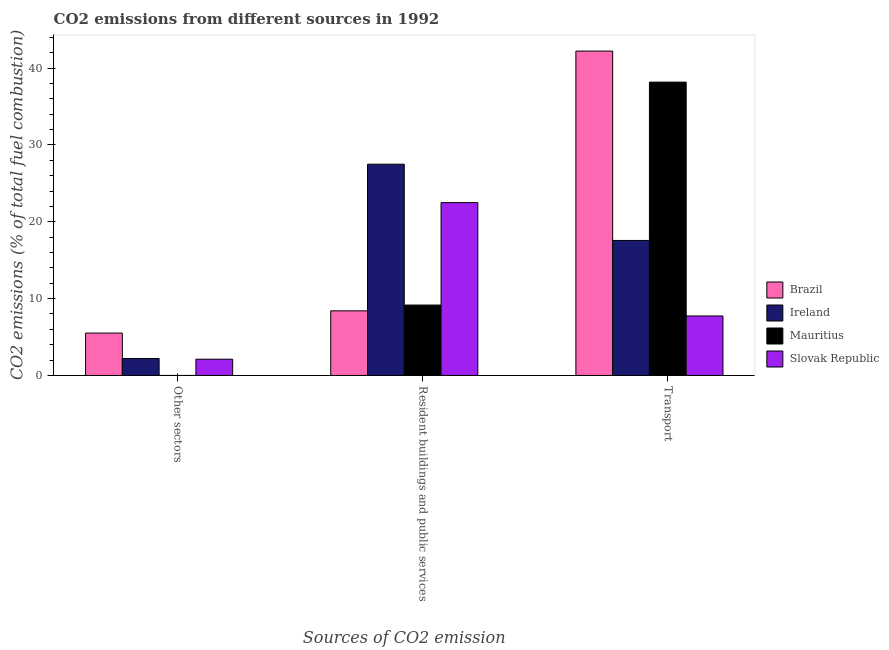How many different coloured bars are there?
Your response must be concise. 4. How many bars are there on the 1st tick from the left?
Ensure brevity in your answer.  3. How many bars are there on the 1st tick from the right?
Keep it short and to the point. 4. What is the label of the 1st group of bars from the left?
Your answer should be very brief. Other sectors. What is the percentage of co2 emissions from transport in Brazil?
Provide a succinct answer. 42.2. Across all countries, what is the maximum percentage of co2 emissions from resident buildings and public services?
Offer a very short reply. 27.49. Across all countries, what is the minimum percentage of co2 emissions from transport?
Your response must be concise. 7.74. In which country was the percentage of co2 emissions from transport maximum?
Offer a very short reply. Brazil. What is the total percentage of co2 emissions from transport in the graph?
Offer a very short reply. 105.68. What is the difference between the percentage of co2 emissions from other sectors in Ireland and that in Brazil?
Offer a terse response. -3.31. What is the difference between the percentage of co2 emissions from other sectors in Mauritius and the percentage of co2 emissions from transport in Slovak Republic?
Give a very brief answer. -7.74. What is the average percentage of co2 emissions from transport per country?
Offer a terse response. 26.42. What is the difference between the percentage of co2 emissions from other sectors and percentage of co2 emissions from transport in Brazil?
Your answer should be compact. -36.69. In how many countries, is the percentage of co2 emissions from resident buildings and public services greater than 34 %?
Offer a terse response. 0. What is the ratio of the percentage of co2 emissions from resident buildings and public services in Brazil to that in Ireland?
Provide a succinct answer. 0.31. Is the percentage of co2 emissions from resident buildings and public services in Mauritius less than that in Brazil?
Keep it short and to the point. No. Is the difference between the percentage of co2 emissions from resident buildings and public services in Slovak Republic and Ireland greater than the difference between the percentage of co2 emissions from other sectors in Slovak Republic and Ireland?
Give a very brief answer. No. What is the difference between the highest and the second highest percentage of co2 emissions from resident buildings and public services?
Provide a short and direct response. 5. What is the difference between the highest and the lowest percentage of co2 emissions from resident buildings and public services?
Offer a very short reply. 19.08. In how many countries, is the percentage of co2 emissions from transport greater than the average percentage of co2 emissions from transport taken over all countries?
Provide a succinct answer. 2. Is it the case that in every country, the sum of the percentage of co2 emissions from other sectors and percentage of co2 emissions from resident buildings and public services is greater than the percentage of co2 emissions from transport?
Your answer should be very brief. No. Are all the bars in the graph horizontal?
Offer a very short reply. No. How many countries are there in the graph?
Your answer should be very brief. 4. Where does the legend appear in the graph?
Offer a terse response. Center right. How are the legend labels stacked?
Offer a very short reply. Vertical. What is the title of the graph?
Offer a very short reply. CO2 emissions from different sources in 1992. What is the label or title of the X-axis?
Offer a very short reply. Sources of CO2 emission. What is the label or title of the Y-axis?
Offer a very short reply. CO2 emissions (% of total fuel combustion). What is the CO2 emissions (% of total fuel combustion) of Brazil in Other sectors?
Give a very brief answer. 5.51. What is the CO2 emissions (% of total fuel combustion) of Ireland in Other sectors?
Provide a succinct answer. 2.21. What is the CO2 emissions (% of total fuel combustion) in Mauritius in Other sectors?
Ensure brevity in your answer.  0. What is the CO2 emissions (% of total fuel combustion) of Slovak Republic in Other sectors?
Your answer should be very brief. 2.12. What is the CO2 emissions (% of total fuel combustion) in Brazil in Resident buildings and public services?
Ensure brevity in your answer.  8.41. What is the CO2 emissions (% of total fuel combustion) of Ireland in Resident buildings and public services?
Ensure brevity in your answer.  27.49. What is the CO2 emissions (% of total fuel combustion) in Mauritius in Resident buildings and public services?
Offer a very short reply. 9.16. What is the CO2 emissions (% of total fuel combustion) of Slovak Republic in Resident buildings and public services?
Your answer should be very brief. 22.49. What is the CO2 emissions (% of total fuel combustion) in Brazil in Transport?
Keep it short and to the point. 42.2. What is the CO2 emissions (% of total fuel combustion) in Ireland in Transport?
Your response must be concise. 17.57. What is the CO2 emissions (% of total fuel combustion) in Mauritius in Transport?
Your answer should be compact. 38.17. What is the CO2 emissions (% of total fuel combustion) in Slovak Republic in Transport?
Your response must be concise. 7.74. Across all Sources of CO2 emission, what is the maximum CO2 emissions (% of total fuel combustion) in Brazil?
Your response must be concise. 42.2. Across all Sources of CO2 emission, what is the maximum CO2 emissions (% of total fuel combustion) in Ireland?
Ensure brevity in your answer.  27.49. Across all Sources of CO2 emission, what is the maximum CO2 emissions (% of total fuel combustion) in Mauritius?
Offer a terse response. 38.17. Across all Sources of CO2 emission, what is the maximum CO2 emissions (% of total fuel combustion) of Slovak Republic?
Your answer should be compact. 22.49. Across all Sources of CO2 emission, what is the minimum CO2 emissions (% of total fuel combustion) in Brazil?
Your answer should be compact. 5.51. Across all Sources of CO2 emission, what is the minimum CO2 emissions (% of total fuel combustion) in Ireland?
Offer a terse response. 2.21. Across all Sources of CO2 emission, what is the minimum CO2 emissions (% of total fuel combustion) of Slovak Republic?
Your answer should be very brief. 2.12. What is the total CO2 emissions (% of total fuel combustion) of Brazil in the graph?
Offer a terse response. 56.13. What is the total CO2 emissions (% of total fuel combustion) of Ireland in the graph?
Keep it short and to the point. 47.26. What is the total CO2 emissions (% of total fuel combustion) of Mauritius in the graph?
Ensure brevity in your answer.  47.33. What is the total CO2 emissions (% of total fuel combustion) in Slovak Republic in the graph?
Offer a very short reply. 32.35. What is the difference between the CO2 emissions (% of total fuel combustion) in Brazil in Other sectors and that in Resident buildings and public services?
Provide a short and direct response. -2.9. What is the difference between the CO2 emissions (% of total fuel combustion) in Ireland in Other sectors and that in Resident buildings and public services?
Your answer should be compact. -25.28. What is the difference between the CO2 emissions (% of total fuel combustion) in Slovak Republic in Other sectors and that in Resident buildings and public services?
Offer a terse response. -20.37. What is the difference between the CO2 emissions (% of total fuel combustion) of Brazil in Other sectors and that in Transport?
Provide a short and direct response. -36.69. What is the difference between the CO2 emissions (% of total fuel combustion) in Ireland in Other sectors and that in Transport?
Give a very brief answer. -15.36. What is the difference between the CO2 emissions (% of total fuel combustion) in Slovak Republic in Other sectors and that in Transport?
Keep it short and to the point. -5.62. What is the difference between the CO2 emissions (% of total fuel combustion) of Brazil in Resident buildings and public services and that in Transport?
Offer a terse response. -33.79. What is the difference between the CO2 emissions (% of total fuel combustion) in Ireland in Resident buildings and public services and that in Transport?
Give a very brief answer. 9.92. What is the difference between the CO2 emissions (% of total fuel combustion) in Mauritius in Resident buildings and public services and that in Transport?
Offer a very short reply. -29.01. What is the difference between the CO2 emissions (% of total fuel combustion) in Slovak Republic in Resident buildings and public services and that in Transport?
Keep it short and to the point. 14.75. What is the difference between the CO2 emissions (% of total fuel combustion) in Brazil in Other sectors and the CO2 emissions (% of total fuel combustion) in Ireland in Resident buildings and public services?
Your answer should be very brief. -21.97. What is the difference between the CO2 emissions (% of total fuel combustion) in Brazil in Other sectors and the CO2 emissions (% of total fuel combustion) in Mauritius in Resident buildings and public services?
Keep it short and to the point. -3.65. What is the difference between the CO2 emissions (% of total fuel combustion) of Brazil in Other sectors and the CO2 emissions (% of total fuel combustion) of Slovak Republic in Resident buildings and public services?
Offer a very short reply. -16.98. What is the difference between the CO2 emissions (% of total fuel combustion) in Ireland in Other sectors and the CO2 emissions (% of total fuel combustion) in Mauritius in Resident buildings and public services?
Provide a succinct answer. -6.95. What is the difference between the CO2 emissions (% of total fuel combustion) of Ireland in Other sectors and the CO2 emissions (% of total fuel combustion) of Slovak Republic in Resident buildings and public services?
Keep it short and to the point. -20.28. What is the difference between the CO2 emissions (% of total fuel combustion) of Brazil in Other sectors and the CO2 emissions (% of total fuel combustion) of Ireland in Transport?
Provide a short and direct response. -12.05. What is the difference between the CO2 emissions (% of total fuel combustion) in Brazil in Other sectors and the CO2 emissions (% of total fuel combustion) in Mauritius in Transport?
Provide a short and direct response. -32.65. What is the difference between the CO2 emissions (% of total fuel combustion) in Brazil in Other sectors and the CO2 emissions (% of total fuel combustion) in Slovak Republic in Transport?
Provide a short and direct response. -2.23. What is the difference between the CO2 emissions (% of total fuel combustion) in Ireland in Other sectors and the CO2 emissions (% of total fuel combustion) in Mauritius in Transport?
Provide a short and direct response. -35.96. What is the difference between the CO2 emissions (% of total fuel combustion) in Ireland in Other sectors and the CO2 emissions (% of total fuel combustion) in Slovak Republic in Transport?
Your answer should be very brief. -5.53. What is the difference between the CO2 emissions (% of total fuel combustion) of Brazil in Resident buildings and public services and the CO2 emissions (% of total fuel combustion) of Ireland in Transport?
Make the answer very short. -9.16. What is the difference between the CO2 emissions (% of total fuel combustion) in Brazil in Resident buildings and public services and the CO2 emissions (% of total fuel combustion) in Mauritius in Transport?
Ensure brevity in your answer.  -29.76. What is the difference between the CO2 emissions (% of total fuel combustion) of Brazil in Resident buildings and public services and the CO2 emissions (% of total fuel combustion) of Slovak Republic in Transport?
Your answer should be very brief. 0.67. What is the difference between the CO2 emissions (% of total fuel combustion) in Ireland in Resident buildings and public services and the CO2 emissions (% of total fuel combustion) in Mauritius in Transport?
Your response must be concise. -10.68. What is the difference between the CO2 emissions (% of total fuel combustion) of Ireland in Resident buildings and public services and the CO2 emissions (% of total fuel combustion) of Slovak Republic in Transport?
Your answer should be very brief. 19.75. What is the difference between the CO2 emissions (% of total fuel combustion) in Mauritius in Resident buildings and public services and the CO2 emissions (% of total fuel combustion) in Slovak Republic in Transport?
Your answer should be compact. 1.42. What is the average CO2 emissions (% of total fuel combustion) in Brazil per Sources of CO2 emission?
Your answer should be compact. 18.71. What is the average CO2 emissions (% of total fuel combustion) in Ireland per Sources of CO2 emission?
Your answer should be compact. 15.75. What is the average CO2 emissions (% of total fuel combustion) in Mauritius per Sources of CO2 emission?
Your answer should be compact. 15.78. What is the average CO2 emissions (% of total fuel combustion) in Slovak Republic per Sources of CO2 emission?
Offer a very short reply. 10.78. What is the difference between the CO2 emissions (% of total fuel combustion) in Brazil and CO2 emissions (% of total fuel combustion) in Ireland in Other sectors?
Make the answer very short. 3.31. What is the difference between the CO2 emissions (% of total fuel combustion) of Brazil and CO2 emissions (% of total fuel combustion) of Slovak Republic in Other sectors?
Ensure brevity in your answer.  3.4. What is the difference between the CO2 emissions (% of total fuel combustion) of Ireland and CO2 emissions (% of total fuel combustion) of Slovak Republic in Other sectors?
Keep it short and to the point. 0.09. What is the difference between the CO2 emissions (% of total fuel combustion) of Brazil and CO2 emissions (% of total fuel combustion) of Ireland in Resident buildings and public services?
Your response must be concise. -19.08. What is the difference between the CO2 emissions (% of total fuel combustion) of Brazil and CO2 emissions (% of total fuel combustion) of Mauritius in Resident buildings and public services?
Your answer should be compact. -0.75. What is the difference between the CO2 emissions (% of total fuel combustion) in Brazil and CO2 emissions (% of total fuel combustion) in Slovak Republic in Resident buildings and public services?
Ensure brevity in your answer.  -14.08. What is the difference between the CO2 emissions (% of total fuel combustion) in Ireland and CO2 emissions (% of total fuel combustion) in Mauritius in Resident buildings and public services?
Your answer should be compact. 18.33. What is the difference between the CO2 emissions (% of total fuel combustion) of Ireland and CO2 emissions (% of total fuel combustion) of Slovak Republic in Resident buildings and public services?
Ensure brevity in your answer.  5. What is the difference between the CO2 emissions (% of total fuel combustion) of Mauritius and CO2 emissions (% of total fuel combustion) of Slovak Republic in Resident buildings and public services?
Provide a short and direct response. -13.33. What is the difference between the CO2 emissions (% of total fuel combustion) in Brazil and CO2 emissions (% of total fuel combustion) in Ireland in Transport?
Your answer should be very brief. 24.64. What is the difference between the CO2 emissions (% of total fuel combustion) of Brazil and CO2 emissions (% of total fuel combustion) of Mauritius in Transport?
Your answer should be compact. 4.04. What is the difference between the CO2 emissions (% of total fuel combustion) of Brazil and CO2 emissions (% of total fuel combustion) of Slovak Republic in Transport?
Provide a succinct answer. 34.46. What is the difference between the CO2 emissions (% of total fuel combustion) in Ireland and CO2 emissions (% of total fuel combustion) in Mauritius in Transport?
Offer a terse response. -20.6. What is the difference between the CO2 emissions (% of total fuel combustion) of Ireland and CO2 emissions (% of total fuel combustion) of Slovak Republic in Transport?
Provide a succinct answer. 9.83. What is the difference between the CO2 emissions (% of total fuel combustion) in Mauritius and CO2 emissions (% of total fuel combustion) in Slovak Republic in Transport?
Provide a short and direct response. 30.43. What is the ratio of the CO2 emissions (% of total fuel combustion) of Brazil in Other sectors to that in Resident buildings and public services?
Keep it short and to the point. 0.66. What is the ratio of the CO2 emissions (% of total fuel combustion) of Ireland in Other sectors to that in Resident buildings and public services?
Offer a very short reply. 0.08. What is the ratio of the CO2 emissions (% of total fuel combustion) in Slovak Republic in Other sectors to that in Resident buildings and public services?
Ensure brevity in your answer.  0.09. What is the ratio of the CO2 emissions (% of total fuel combustion) of Brazil in Other sectors to that in Transport?
Offer a very short reply. 0.13. What is the ratio of the CO2 emissions (% of total fuel combustion) in Ireland in Other sectors to that in Transport?
Give a very brief answer. 0.13. What is the ratio of the CO2 emissions (% of total fuel combustion) in Slovak Republic in Other sectors to that in Transport?
Provide a succinct answer. 0.27. What is the ratio of the CO2 emissions (% of total fuel combustion) in Brazil in Resident buildings and public services to that in Transport?
Provide a short and direct response. 0.2. What is the ratio of the CO2 emissions (% of total fuel combustion) of Ireland in Resident buildings and public services to that in Transport?
Provide a succinct answer. 1.56. What is the ratio of the CO2 emissions (% of total fuel combustion) of Mauritius in Resident buildings and public services to that in Transport?
Ensure brevity in your answer.  0.24. What is the ratio of the CO2 emissions (% of total fuel combustion) of Slovak Republic in Resident buildings and public services to that in Transport?
Give a very brief answer. 2.91. What is the difference between the highest and the second highest CO2 emissions (% of total fuel combustion) of Brazil?
Your answer should be very brief. 33.79. What is the difference between the highest and the second highest CO2 emissions (% of total fuel combustion) of Ireland?
Your answer should be very brief. 9.92. What is the difference between the highest and the second highest CO2 emissions (% of total fuel combustion) in Slovak Republic?
Your response must be concise. 14.75. What is the difference between the highest and the lowest CO2 emissions (% of total fuel combustion) of Brazil?
Keep it short and to the point. 36.69. What is the difference between the highest and the lowest CO2 emissions (% of total fuel combustion) of Ireland?
Offer a very short reply. 25.28. What is the difference between the highest and the lowest CO2 emissions (% of total fuel combustion) in Mauritius?
Your response must be concise. 38.17. What is the difference between the highest and the lowest CO2 emissions (% of total fuel combustion) in Slovak Republic?
Provide a short and direct response. 20.37. 